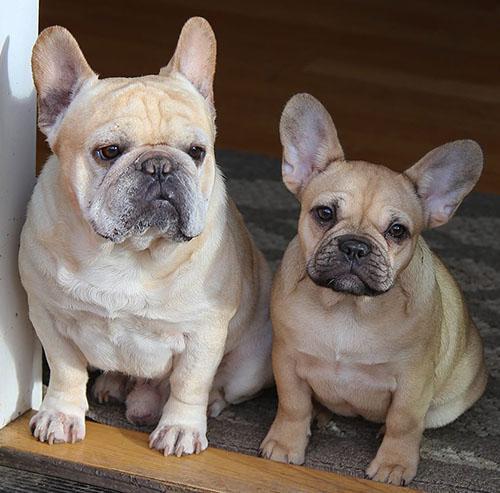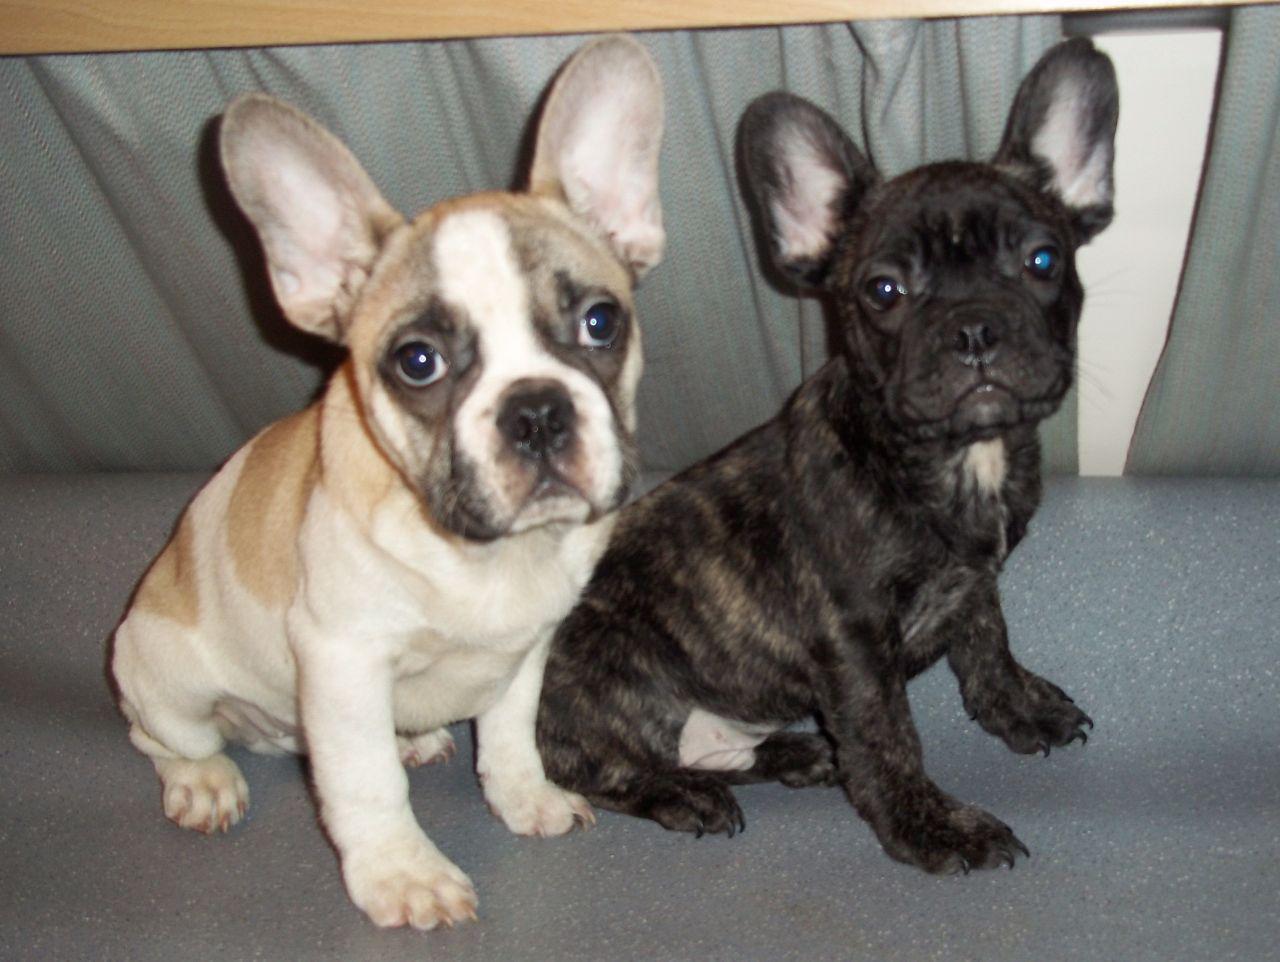The first image is the image on the left, the second image is the image on the right. Analyze the images presented: Is the assertion "The left image contains exactly two dogs." valid? Answer yes or no. Yes. The first image is the image on the left, the second image is the image on the right. Considering the images on both sides, is "Each image contains exactly two bulldogs, and the two dogs on the left are the same color, while the right image features a dark dog next to a lighter one." valid? Answer yes or no. Yes. 